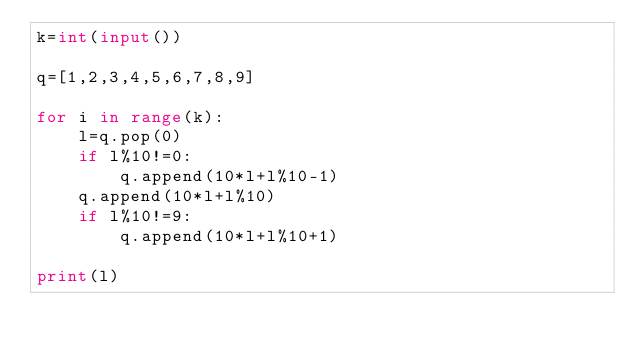<code> <loc_0><loc_0><loc_500><loc_500><_Python_>k=int(input())

q=[1,2,3,4,5,6,7,8,9]

for i in range(k):
    l=q.pop(0)
    if l%10!=0:
        q.append(10*l+l%10-1)
    q.append(10*l+l%10)
    if l%10!=9:
        q.append(10*l+l%10+1)
    
print(l)
</code> 